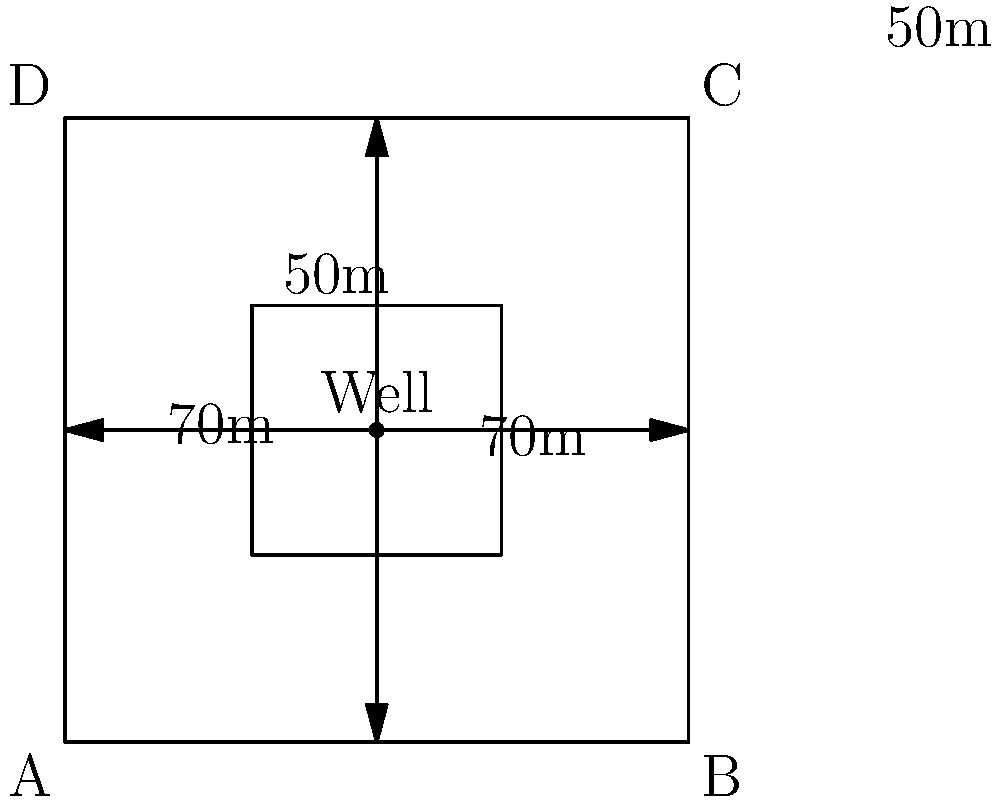A square farm plot measures 100m x 100m with a central well. The farmer wants to install an irrigation system to water four equal square sections (30m x 30m each) in the corners of the plot. Given that irrigation pipe costs $2.50 per meter for second-hand materials, what is the most cost-effective layout for the irrigation system, and what is its total cost? To determine the most cost-effective irrigation layout, we need to calculate the total length of pipe required for different configurations and choose the shortest one.

1. Calculate distances:
   - Well to corner of inner square: $\sqrt{20^2 + 20^2} = 20\sqrt{2} \approx 28.28$ m
   - Well to middle of plot side: 50 m

2. Consider two possible layouts:
   a) Direct lines from well to each inner square corner
   b) Lines from well to middle of each side, then to inner square corners

3. Calculate total pipe length for each layout:
   a) Direct lines: $4 * 28.28 = 113.12$ m
   b) Side approach: $(4 * 50) + (4 * 20) = 280$ m

4. The direct line approach (a) is shorter and thus more cost-effective.

5. Calculate total cost:
   Cost = Pipe length * Cost per meter
   Cost = $113.12 * $2.50 = $282.80$

Therefore, the most cost-effective layout is running pipes directly from the well to each inner square corner.
Answer: Direct lines from well to inner square corners; $282.80 